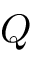<formula> <loc_0><loc_0><loc_500><loc_500>Q</formula> 